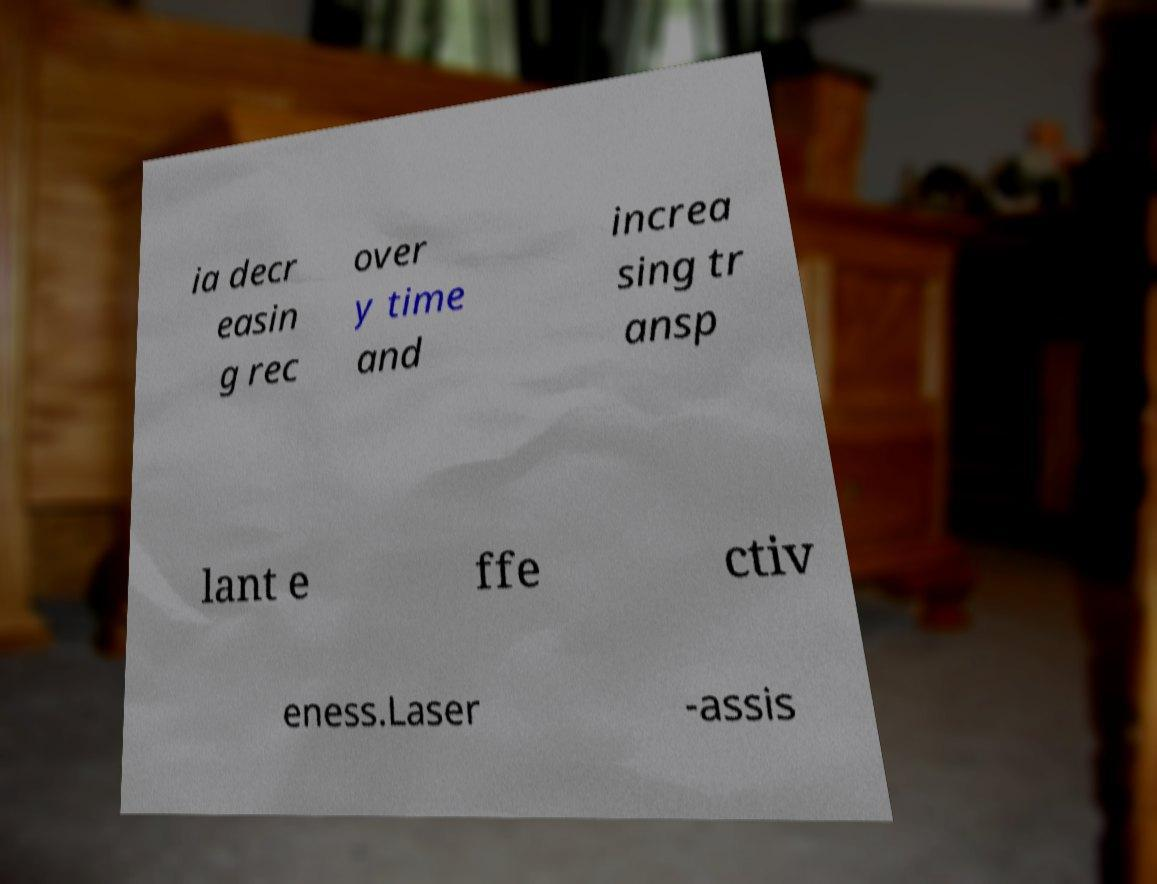Please identify and transcribe the text found in this image. ia decr easin g rec over y time and increa sing tr ansp lant e ffe ctiv eness.Laser -assis 